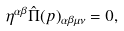<formula> <loc_0><loc_0><loc_500><loc_500>\eta ^ { \alpha \beta } \hat { \Pi } ( p ) _ { \alpha \beta \mu \nu } = 0 ,</formula> 